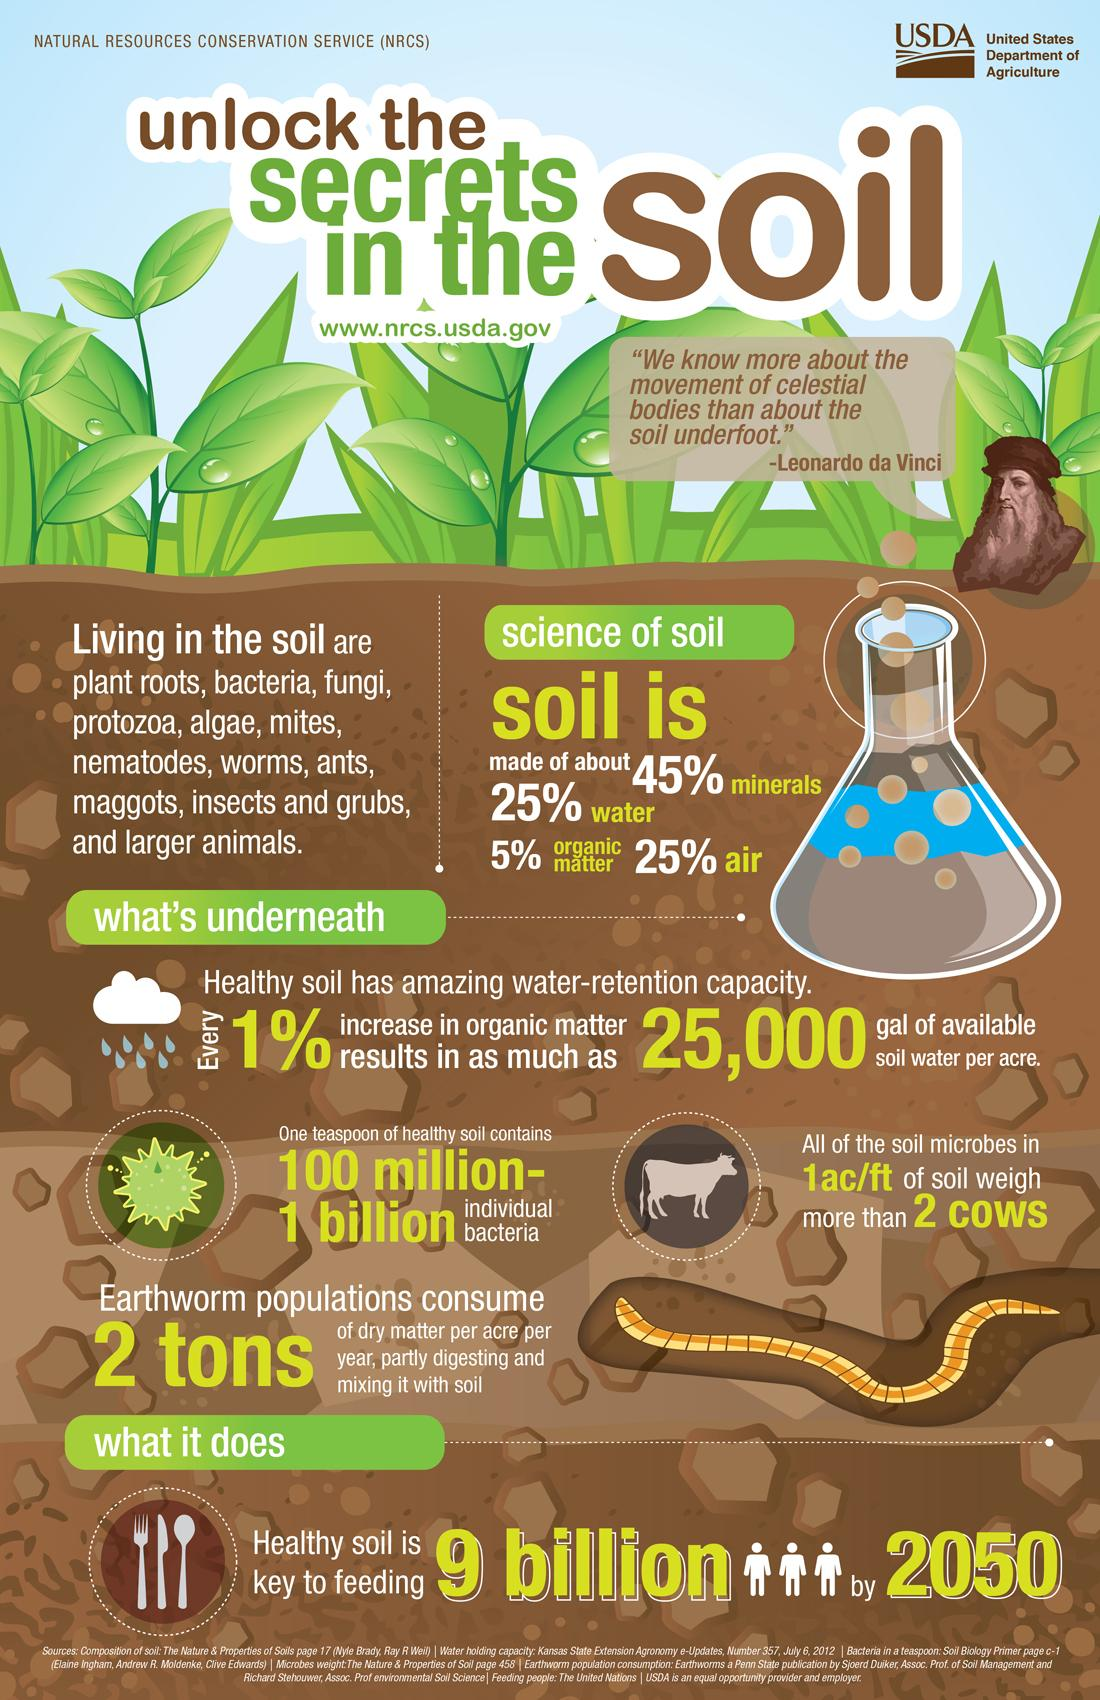Indicate a few pertinent items in this graphic. According to a recent study, only 45% of soil is comprised of minerals. According to a recent study, only 25% of soil is made up of water. Seventy-five percent of soil is not air. According to recent research, only 5% of soil is made up of inorganic matter, while the remaining 95% is composed of organic matter. 